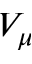Convert formula to latex. <formula><loc_0><loc_0><loc_500><loc_500>V _ { \mu }</formula> 